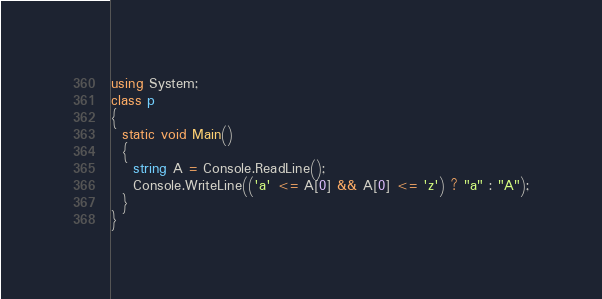<code> <loc_0><loc_0><loc_500><loc_500><_C#_>using System;
class p
{
  static void Main()
  {
    string A = Console.ReadLine();
    Console.WriteLine(('a' <= A[0] && A[0] <= 'z') ? "a" : "A");
  }
}</code> 